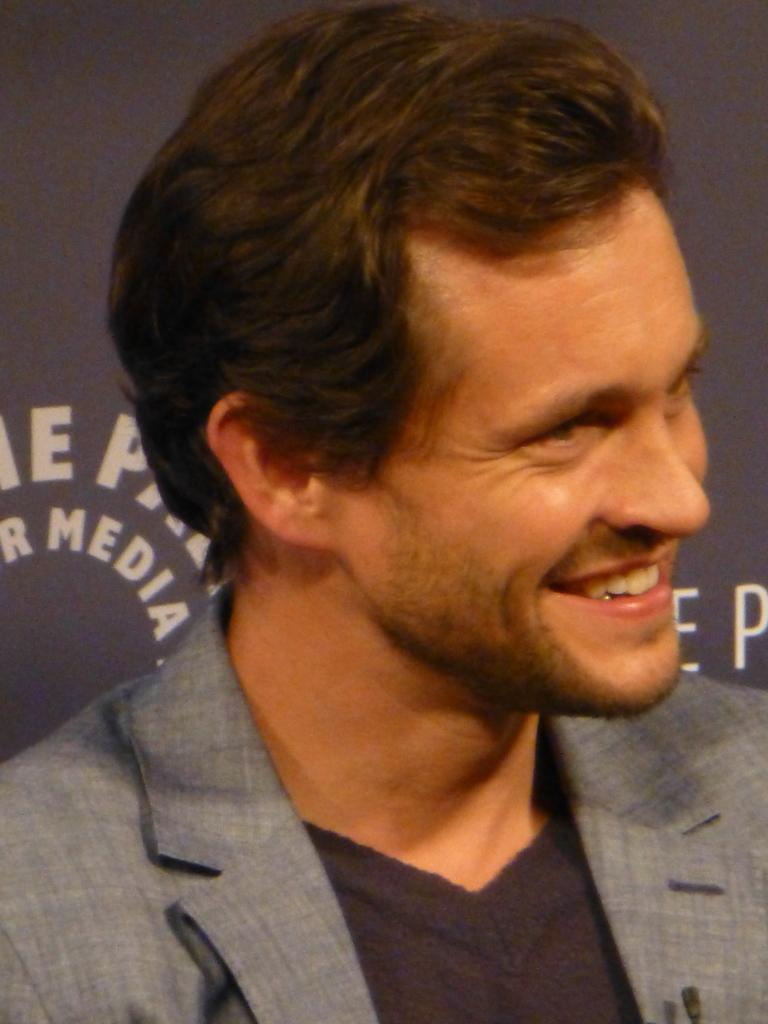Who is the main subject in the image? There is a person in the center of the image. What is the person doing in the image? The person is smiling. What can be seen in the background of the image? There is a banner in the background of the image. What type of hydrant is present in the image? There is no hydrant present in the image. What kind of suit is the person wearing in the image? The provided facts do not mention the person's clothing, so we cannot determine if they are wearing a suit or not. 